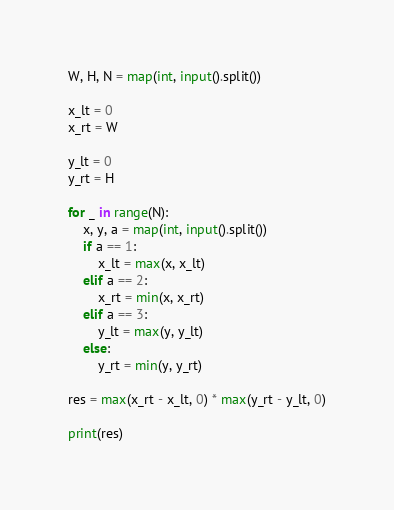Convert code to text. <code><loc_0><loc_0><loc_500><loc_500><_Python_>W, H, N = map(int, input().split())

x_lt = 0
x_rt = W

y_lt = 0
y_rt = H

for _ in range(N):
    x, y, a = map(int, input().split())
    if a == 1:
        x_lt = max(x, x_lt)
    elif a == 2:
        x_rt = min(x, x_rt)
    elif a == 3:
        y_lt = max(y, y_lt)
    else:
        y_rt = min(y, y_rt)

res = max(x_rt - x_lt, 0) * max(y_rt - y_lt, 0)

print(res)</code> 